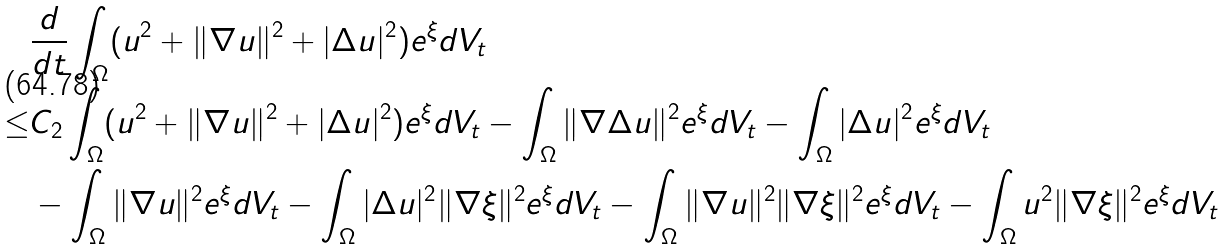<formula> <loc_0><loc_0><loc_500><loc_500>& \frac { d } { d t } \int _ { \Omega } ( u ^ { 2 } + \| \nabla u \| ^ { 2 } + | \Delta u | ^ { 2 } ) e ^ { \xi } d V _ { t } \\ \leq & C _ { 2 } \int _ { \Omega } ( u ^ { 2 } + \| \nabla u \| ^ { 2 } + | \Delta u | ^ { 2 } ) e ^ { \xi } d V _ { t } - \int _ { \Omega } \| \nabla \Delta u \| ^ { 2 } e ^ { \xi } d V _ { t } - \int _ { \Omega } | \Delta u | ^ { 2 } e ^ { \xi } d V _ { t } \\ & - \int _ { \Omega } \| \nabla u \| ^ { 2 } e ^ { \xi } d V _ { t } - \int _ { \Omega } | \Delta u | ^ { 2 } \| \nabla \xi \| ^ { 2 } e ^ { \xi } d V _ { t } - \int _ { \Omega } \| \nabla u \| ^ { 2 } \| \nabla \xi \| ^ { 2 } e ^ { \xi } d V _ { t } - \int _ { \Omega } u ^ { 2 } \| \nabla \xi \| ^ { 2 } e ^ { \xi } d V _ { t } \\</formula> 